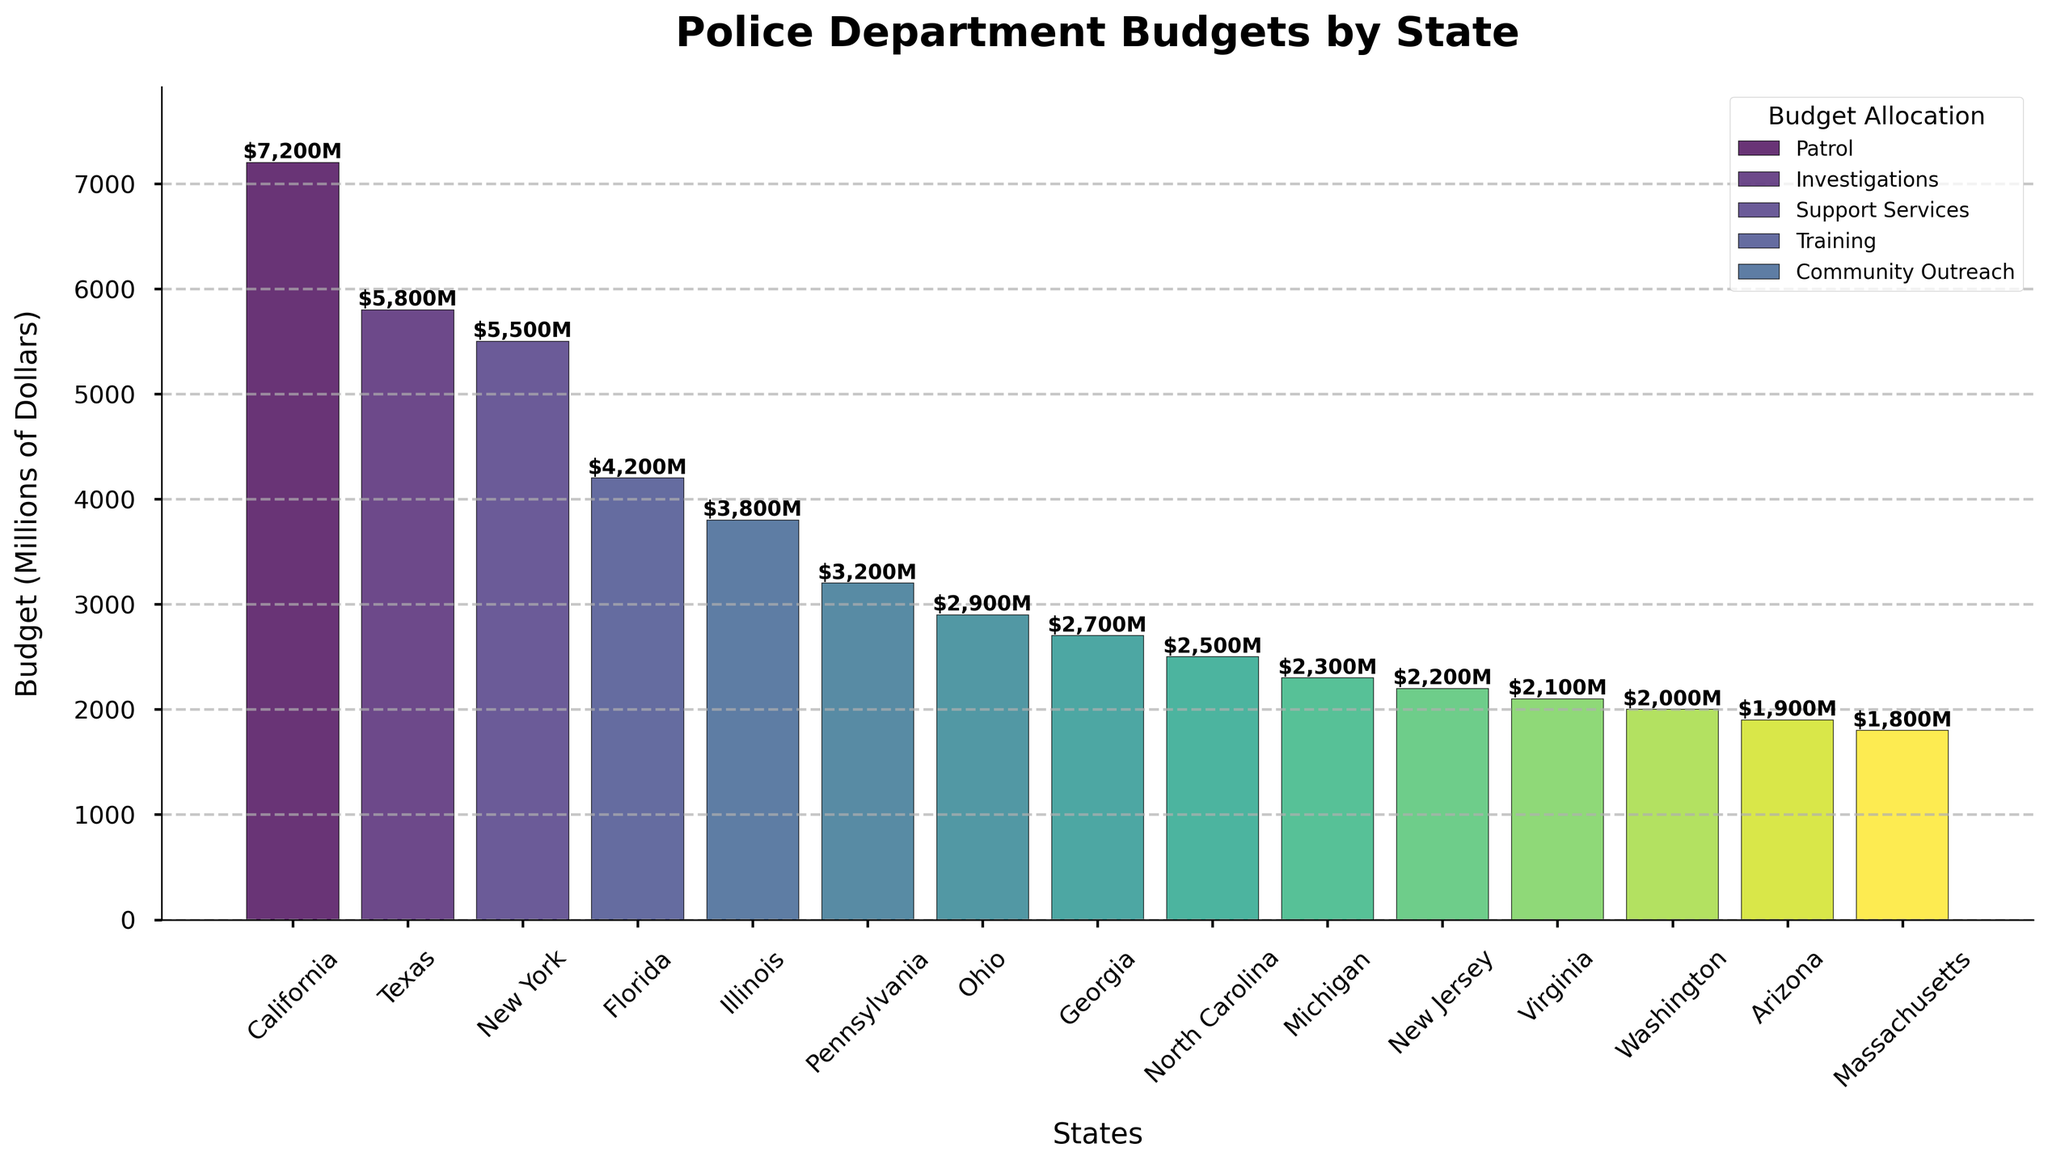Which state has the highest police department budget? The tallest bar in the bar chart represents the state with the highest budget.
Answer: California What is the combined budget of Illinois and Pennsylvania? Illinois has a budget of $3,800 million and Pennsylvania has a budget of $3,200 million. Adding these amounts gives $3,800M + $3,200M = $7,000M.
Answer: $7,000M Which state allocates the highest percentage of its budget to Patrol? According to the legend and bar heights, Florida and Georgia both allocate 43% of their budgets to Patrol.
Answer: Florida and Georgia How much more is New York's budget than Virginia's budget? New York's budget is $5,500 million and Virginia's budget is $2,100 million. The difference is $5,500M - $2,100M = $3,400M.
Answer: $3,400M Which states have an equal percentage allocation for Community Outreach? By examining the breakdown percentages, Texas, New York, Illinois, Pennsylvania, Ohio, Georgia, New Jersey, and Virginia all allocate 8% to Community Outreach.
Answer: Texas, New York, Illinois, Pennsylvania, Ohio, Georgia, New Jersey, and Virginia Which state has the lowest allocation percentage to Training? Texas allocates 12% to Training, the highest among the states listed. The states with lower allocation percentages to Training are California, Florida, Georgia, North Carolina, Michigan, and Arizona, each allocating 10%. Adjusting this previous state summary to accurately reflect only one state with the lowest allocation, Massachusetts is excluded given its equal or higher allocations comparative to other states.
Answer: California, Florida, Georgia, North Carolina, Michigan, and Arizona What is the average police department budget of California, Texas, Florida, and New York? Adding the budgets of California ($7,200M), Texas ($5,800M), Florida ($4,200M), and New York ($5,500M) gives $22,700M. Dividing by 4 yields $22,700M / 4 = $5,675M.
Answer: $5,675M Which state allocates the largest percentage to Investigations? The bar heights and percentages show Illinois and Massachusetts both allocate 26% to Investigations, the highest among the states listed.
Answer: Illinois and Massachusetts What is the difference in budget allocation percentage to Support Services between California and Arizona? California allocates 20% and Arizona allocates 18% to Support Services. The difference is 20% - 18% = 2%.
Answer: 2% 